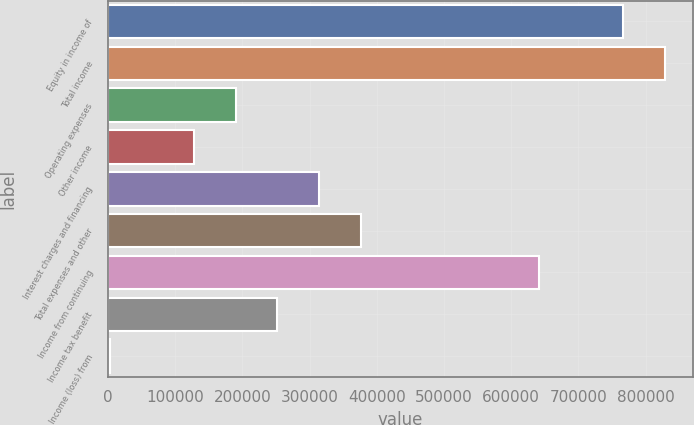<chart> <loc_0><loc_0><loc_500><loc_500><bar_chart><fcel>Equity in income of<fcel>Total income<fcel>Operating expenses<fcel>Other income<fcel>Interest charges and financing<fcel>Total expenses and other<fcel>Income from continuing<fcel>Income tax benefit<fcel>Income (loss) from<nl><fcel>766247<fcel>828470<fcel>189740<fcel>127518<fcel>314186<fcel>376408<fcel>641802<fcel>251963<fcel>3073<nl></chart> 